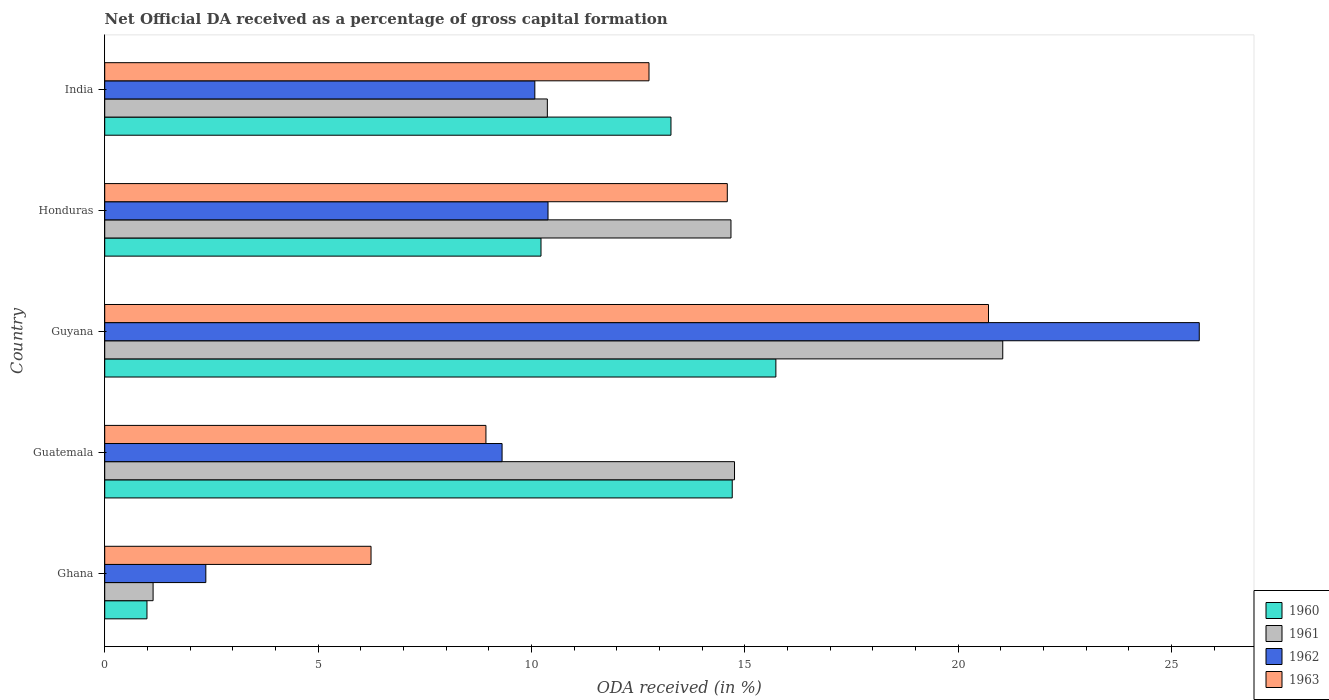Are the number of bars on each tick of the Y-axis equal?
Offer a terse response. Yes. How many bars are there on the 3rd tick from the bottom?
Offer a very short reply. 4. What is the label of the 5th group of bars from the top?
Offer a very short reply. Ghana. In how many cases, is the number of bars for a given country not equal to the number of legend labels?
Provide a succinct answer. 0. What is the net ODA received in 1960 in Honduras?
Offer a terse response. 10.23. Across all countries, what is the maximum net ODA received in 1963?
Make the answer very short. 20.71. Across all countries, what is the minimum net ODA received in 1962?
Make the answer very short. 2.37. In which country was the net ODA received in 1961 maximum?
Your answer should be compact. Guyana. In which country was the net ODA received in 1963 minimum?
Your answer should be compact. Ghana. What is the total net ODA received in 1961 in the graph?
Offer a terse response. 61.99. What is the difference between the net ODA received in 1961 in Guatemala and that in Honduras?
Your answer should be compact. 0.08. What is the difference between the net ODA received in 1962 in Guyana and the net ODA received in 1960 in Guatemala?
Give a very brief answer. 10.95. What is the average net ODA received in 1962 per country?
Give a very brief answer. 11.56. What is the difference between the net ODA received in 1963 and net ODA received in 1961 in Honduras?
Give a very brief answer. -0.09. In how many countries, is the net ODA received in 1962 greater than 24 %?
Give a very brief answer. 1. What is the ratio of the net ODA received in 1961 in Ghana to that in Honduras?
Provide a short and direct response. 0.08. What is the difference between the highest and the second highest net ODA received in 1960?
Your answer should be very brief. 1.02. What is the difference between the highest and the lowest net ODA received in 1960?
Give a very brief answer. 14.74. Is the sum of the net ODA received in 1961 in Ghana and Guyana greater than the maximum net ODA received in 1962 across all countries?
Your answer should be very brief. No. What does the 4th bar from the top in Guatemala represents?
Keep it short and to the point. 1960. What does the 2nd bar from the bottom in Guatemala represents?
Ensure brevity in your answer.  1961. Is it the case that in every country, the sum of the net ODA received in 1960 and net ODA received in 1963 is greater than the net ODA received in 1962?
Your answer should be compact. Yes. Where does the legend appear in the graph?
Provide a succinct answer. Bottom right. How are the legend labels stacked?
Your answer should be very brief. Vertical. What is the title of the graph?
Ensure brevity in your answer.  Net Official DA received as a percentage of gross capital formation. What is the label or title of the X-axis?
Offer a very short reply. ODA received (in %). What is the label or title of the Y-axis?
Your answer should be very brief. Country. What is the ODA received (in %) in 1960 in Ghana?
Offer a terse response. 0.99. What is the ODA received (in %) in 1961 in Ghana?
Keep it short and to the point. 1.13. What is the ODA received (in %) in 1962 in Ghana?
Make the answer very short. 2.37. What is the ODA received (in %) of 1963 in Ghana?
Offer a terse response. 6.24. What is the ODA received (in %) in 1960 in Guatemala?
Provide a short and direct response. 14.71. What is the ODA received (in %) of 1961 in Guatemala?
Your answer should be very brief. 14.76. What is the ODA received (in %) in 1962 in Guatemala?
Ensure brevity in your answer.  9.31. What is the ODA received (in %) in 1963 in Guatemala?
Give a very brief answer. 8.93. What is the ODA received (in %) in 1960 in Guyana?
Offer a very short reply. 15.73. What is the ODA received (in %) of 1961 in Guyana?
Provide a short and direct response. 21.05. What is the ODA received (in %) in 1962 in Guyana?
Keep it short and to the point. 25.65. What is the ODA received (in %) of 1963 in Guyana?
Ensure brevity in your answer.  20.71. What is the ODA received (in %) of 1960 in Honduras?
Your answer should be very brief. 10.23. What is the ODA received (in %) in 1961 in Honduras?
Provide a succinct answer. 14.68. What is the ODA received (in %) of 1962 in Honduras?
Ensure brevity in your answer.  10.39. What is the ODA received (in %) of 1963 in Honduras?
Give a very brief answer. 14.59. What is the ODA received (in %) in 1960 in India?
Offer a terse response. 13.27. What is the ODA received (in %) in 1961 in India?
Your response must be concise. 10.37. What is the ODA received (in %) of 1962 in India?
Offer a terse response. 10.08. What is the ODA received (in %) of 1963 in India?
Offer a terse response. 12.76. Across all countries, what is the maximum ODA received (in %) of 1960?
Provide a succinct answer. 15.73. Across all countries, what is the maximum ODA received (in %) in 1961?
Offer a very short reply. 21.05. Across all countries, what is the maximum ODA received (in %) in 1962?
Make the answer very short. 25.65. Across all countries, what is the maximum ODA received (in %) of 1963?
Your answer should be compact. 20.71. Across all countries, what is the minimum ODA received (in %) in 1960?
Ensure brevity in your answer.  0.99. Across all countries, what is the minimum ODA received (in %) in 1961?
Ensure brevity in your answer.  1.13. Across all countries, what is the minimum ODA received (in %) in 1962?
Your answer should be compact. 2.37. Across all countries, what is the minimum ODA received (in %) in 1963?
Your answer should be very brief. 6.24. What is the total ODA received (in %) in 1960 in the graph?
Provide a short and direct response. 54.92. What is the total ODA received (in %) of 1961 in the graph?
Make the answer very short. 61.99. What is the total ODA received (in %) in 1962 in the graph?
Provide a succinct answer. 57.81. What is the total ODA received (in %) of 1963 in the graph?
Give a very brief answer. 63.24. What is the difference between the ODA received (in %) in 1960 in Ghana and that in Guatemala?
Make the answer very short. -13.72. What is the difference between the ODA received (in %) in 1961 in Ghana and that in Guatemala?
Ensure brevity in your answer.  -13.63. What is the difference between the ODA received (in %) in 1962 in Ghana and that in Guatemala?
Offer a very short reply. -6.94. What is the difference between the ODA received (in %) of 1963 in Ghana and that in Guatemala?
Provide a short and direct response. -2.69. What is the difference between the ODA received (in %) in 1960 in Ghana and that in Guyana?
Keep it short and to the point. -14.74. What is the difference between the ODA received (in %) of 1961 in Ghana and that in Guyana?
Ensure brevity in your answer.  -19.91. What is the difference between the ODA received (in %) in 1962 in Ghana and that in Guyana?
Ensure brevity in your answer.  -23.28. What is the difference between the ODA received (in %) in 1963 in Ghana and that in Guyana?
Your answer should be very brief. -14.47. What is the difference between the ODA received (in %) of 1960 in Ghana and that in Honduras?
Your response must be concise. -9.23. What is the difference between the ODA received (in %) in 1961 in Ghana and that in Honduras?
Your answer should be very brief. -13.54. What is the difference between the ODA received (in %) of 1962 in Ghana and that in Honduras?
Give a very brief answer. -8.02. What is the difference between the ODA received (in %) of 1963 in Ghana and that in Honduras?
Provide a short and direct response. -8.35. What is the difference between the ODA received (in %) in 1960 in Ghana and that in India?
Ensure brevity in your answer.  -12.28. What is the difference between the ODA received (in %) of 1961 in Ghana and that in India?
Keep it short and to the point. -9.24. What is the difference between the ODA received (in %) of 1962 in Ghana and that in India?
Your answer should be compact. -7.71. What is the difference between the ODA received (in %) of 1963 in Ghana and that in India?
Offer a very short reply. -6.51. What is the difference between the ODA received (in %) of 1960 in Guatemala and that in Guyana?
Your answer should be very brief. -1.02. What is the difference between the ODA received (in %) of 1961 in Guatemala and that in Guyana?
Offer a very short reply. -6.29. What is the difference between the ODA received (in %) in 1962 in Guatemala and that in Guyana?
Keep it short and to the point. -16.34. What is the difference between the ODA received (in %) of 1963 in Guatemala and that in Guyana?
Provide a short and direct response. -11.78. What is the difference between the ODA received (in %) of 1960 in Guatemala and that in Honduras?
Give a very brief answer. 4.48. What is the difference between the ODA received (in %) in 1961 in Guatemala and that in Honduras?
Your response must be concise. 0.08. What is the difference between the ODA received (in %) of 1962 in Guatemala and that in Honduras?
Provide a short and direct response. -1.08. What is the difference between the ODA received (in %) in 1963 in Guatemala and that in Honduras?
Provide a short and direct response. -5.66. What is the difference between the ODA received (in %) of 1960 in Guatemala and that in India?
Ensure brevity in your answer.  1.44. What is the difference between the ODA received (in %) in 1961 in Guatemala and that in India?
Keep it short and to the point. 4.39. What is the difference between the ODA received (in %) in 1962 in Guatemala and that in India?
Keep it short and to the point. -0.77. What is the difference between the ODA received (in %) of 1963 in Guatemala and that in India?
Your answer should be very brief. -3.82. What is the difference between the ODA received (in %) of 1960 in Guyana and that in Honduras?
Your response must be concise. 5.5. What is the difference between the ODA received (in %) in 1961 in Guyana and that in Honduras?
Your answer should be compact. 6.37. What is the difference between the ODA received (in %) of 1962 in Guyana and that in Honduras?
Your response must be concise. 15.26. What is the difference between the ODA received (in %) of 1963 in Guyana and that in Honduras?
Your response must be concise. 6.12. What is the difference between the ODA received (in %) of 1960 in Guyana and that in India?
Ensure brevity in your answer.  2.46. What is the difference between the ODA received (in %) in 1961 in Guyana and that in India?
Offer a terse response. 10.67. What is the difference between the ODA received (in %) in 1962 in Guyana and that in India?
Give a very brief answer. 15.57. What is the difference between the ODA received (in %) of 1963 in Guyana and that in India?
Offer a very short reply. 7.96. What is the difference between the ODA received (in %) in 1960 in Honduras and that in India?
Give a very brief answer. -3.05. What is the difference between the ODA received (in %) in 1961 in Honduras and that in India?
Your response must be concise. 4.3. What is the difference between the ODA received (in %) in 1962 in Honduras and that in India?
Give a very brief answer. 0.31. What is the difference between the ODA received (in %) of 1963 in Honduras and that in India?
Give a very brief answer. 1.84. What is the difference between the ODA received (in %) of 1960 in Ghana and the ODA received (in %) of 1961 in Guatemala?
Offer a very short reply. -13.77. What is the difference between the ODA received (in %) of 1960 in Ghana and the ODA received (in %) of 1962 in Guatemala?
Give a very brief answer. -8.32. What is the difference between the ODA received (in %) of 1960 in Ghana and the ODA received (in %) of 1963 in Guatemala?
Offer a very short reply. -7.94. What is the difference between the ODA received (in %) in 1961 in Ghana and the ODA received (in %) in 1962 in Guatemala?
Give a very brief answer. -8.18. What is the difference between the ODA received (in %) of 1961 in Ghana and the ODA received (in %) of 1963 in Guatemala?
Offer a terse response. -7.8. What is the difference between the ODA received (in %) of 1962 in Ghana and the ODA received (in %) of 1963 in Guatemala?
Keep it short and to the point. -6.56. What is the difference between the ODA received (in %) of 1960 in Ghana and the ODA received (in %) of 1961 in Guyana?
Provide a succinct answer. -20.06. What is the difference between the ODA received (in %) in 1960 in Ghana and the ODA received (in %) in 1962 in Guyana?
Provide a short and direct response. -24.66. What is the difference between the ODA received (in %) in 1960 in Ghana and the ODA received (in %) in 1963 in Guyana?
Make the answer very short. -19.72. What is the difference between the ODA received (in %) of 1961 in Ghana and the ODA received (in %) of 1962 in Guyana?
Give a very brief answer. -24.52. What is the difference between the ODA received (in %) in 1961 in Ghana and the ODA received (in %) in 1963 in Guyana?
Provide a short and direct response. -19.58. What is the difference between the ODA received (in %) of 1962 in Ghana and the ODA received (in %) of 1963 in Guyana?
Ensure brevity in your answer.  -18.34. What is the difference between the ODA received (in %) of 1960 in Ghana and the ODA received (in %) of 1961 in Honduras?
Offer a terse response. -13.69. What is the difference between the ODA received (in %) in 1960 in Ghana and the ODA received (in %) in 1962 in Honduras?
Ensure brevity in your answer.  -9.4. What is the difference between the ODA received (in %) in 1960 in Ghana and the ODA received (in %) in 1963 in Honduras?
Provide a succinct answer. -13.6. What is the difference between the ODA received (in %) in 1961 in Ghana and the ODA received (in %) in 1962 in Honduras?
Give a very brief answer. -9.26. What is the difference between the ODA received (in %) of 1961 in Ghana and the ODA received (in %) of 1963 in Honduras?
Provide a succinct answer. -13.46. What is the difference between the ODA received (in %) in 1962 in Ghana and the ODA received (in %) in 1963 in Honduras?
Your answer should be compact. -12.22. What is the difference between the ODA received (in %) in 1960 in Ghana and the ODA received (in %) in 1961 in India?
Provide a short and direct response. -9.38. What is the difference between the ODA received (in %) in 1960 in Ghana and the ODA received (in %) in 1962 in India?
Ensure brevity in your answer.  -9.09. What is the difference between the ODA received (in %) of 1960 in Ghana and the ODA received (in %) of 1963 in India?
Provide a succinct answer. -11.77. What is the difference between the ODA received (in %) in 1961 in Ghana and the ODA received (in %) in 1962 in India?
Provide a short and direct response. -8.95. What is the difference between the ODA received (in %) in 1961 in Ghana and the ODA received (in %) in 1963 in India?
Your answer should be very brief. -11.62. What is the difference between the ODA received (in %) of 1962 in Ghana and the ODA received (in %) of 1963 in India?
Make the answer very short. -10.39. What is the difference between the ODA received (in %) in 1960 in Guatemala and the ODA received (in %) in 1961 in Guyana?
Provide a short and direct response. -6.34. What is the difference between the ODA received (in %) of 1960 in Guatemala and the ODA received (in %) of 1962 in Guyana?
Make the answer very short. -10.95. What is the difference between the ODA received (in %) in 1960 in Guatemala and the ODA received (in %) in 1963 in Guyana?
Your answer should be very brief. -6.01. What is the difference between the ODA received (in %) in 1961 in Guatemala and the ODA received (in %) in 1962 in Guyana?
Ensure brevity in your answer.  -10.89. What is the difference between the ODA received (in %) in 1961 in Guatemala and the ODA received (in %) in 1963 in Guyana?
Make the answer very short. -5.95. What is the difference between the ODA received (in %) in 1962 in Guatemala and the ODA received (in %) in 1963 in Guyana?
Offer a terse response. -11.4. What is the difference between the ODA received (in %) of 1960 in Guatemala and the ODA received (in %) of 1961 in Honduras?
Offer a terse response. 0.03. What is the difference between the ODA received (in %) in 1960 in Guatemala and the ODA received (in %) in 1962 in Honduras?
Give a very brief answer. 4.32. What is the difference between the ODA received (in %) in 1960 in Guatemala and the ODA received (in %) in 1963 in Honduras?
Provide a short and direct response. 0.12. What is the difference between the ODA received (in %) in 1961 in Guatemala and the ODA received (in %) in 1962 in Honduras?
Make the answer very short. 4.37. What is the difference between the ODA received (in %) of 1961 in Guatemala and the ODA received (in %) of 1963 in Honduras?
Your response must be concise. 0.17. What is the difference between the ODA received (in %) in 1962 in Guatemala and the ODA received (in %) in 1963 in Honduras?
Give a very brief answer. -5.28. What is the difference between the ODA received (in %) of 1960 in Guatemala and the ODA received (in %) of 1961 in India?
Give a very brief answer. 4.33. What is the difference between the ODA received (in %) of 1960 in Guatemala and the ODA received (in %) of 1962 in India?
Your response must be concise. 4.63. What is the difference between the ODA received (in %) of 1960 in Guatemala and the ODA received (in %) of 1963 in India?
Offer a terse response. 1.95. What is the difference between the ODA received (in %) in 1961 in Guatemala and the ODA received (in %) in 1962 in India?
Provide a succinct answer. 4.68. What is the difference between the ODA received (in %) of 1961 in Guatemala and the ODA received (in %) of 1963 in India?
Ensure brevity in your answer.  2. What is the difference between the ODA received (in %) in 1962 in Guatemala and the ODA received (in %) in 1963 in India?
Offer a terse response. -3.44. What is the difference between the ODA received (in %) in 1960 in Guyana and the ODA received (in %) in 1961 in Honduras?
Offer a terse response. 1.05. What is the difference between the ODA received (in %) of 1960 in Guyana and the ODA received (in %) of 1962 in Honduras?
Keep it short and to the point. 5.34. What is the difference between the ODA received (in %) of 1960 in Guyana and the ODA received (in %) of 1963 in Honduras?
Your answer should be very brief. 1.14. What is the difference between the ODA received (in %) of 1961 in Guyana and the ODA received (in %) of 1962 in Honduras?
Give a very brief answer. 10.66. What is the difference between the ODA received (in %) of 1961 in Guyana and the ODA received (in %) of 1963 in Honduras?
Your response must be concise. 6.46. What is the difference between the ODA received (in %) in 1962 in Guyana and the ODA received (in %) in 1963 in Honduras?
Your answer should be very brief. 11.06. What is the difference between the ODA received (in %) of 1960 in Guyana and the ODA received (in %) of 1961 in India?
Provide a succinct answer. 5.36. What is the difference between the ODA received (in %) in 1960 in Guyana and the ODA received (in %) in 1962 in India?
Give a very brief answer. 5.65. What is the difference between the ODA received (in %) of 1960 in Guyana and the ODA received (in %) of 1963 in India?
Your answer should be very brief. 2.97. What is the difference between the ODA received (in %) in 1961 in Guyana and the ODA received (in %) in 1962 in India?
Give a very brief answer. 10.97. What is the difference between the ODA received (in %) of 1961 in Guyana and the ODA received (in %) of 1963 in India?
Make the answer very short. 8.29. What is the difference between the ODA received (in %) in 1962 in Guyana and the ODA received (in %) in 1963 in India?
Provide a short and direct response. 12.9. What is the difference between the ODA received (in %) in 1960 in Honduras and the ODA received (in %) in 1961 in India?
Provide a short and direct response. -0.15. What is the difference between the ODA received (in %) of 1960 in Honduras and the ODA received (in %) of 1962 in India?
Give a very brief answer. 0.14. What is the difference between the ODA received (in %) in 1960 in Honduras and the ODA received (in %) in 1963 in India?
Your answer should be compact. -2.53. What is the difference between the ODA received (in %) of 1961 in Honduras and the ODA received (in %) of 1962 in India?
Give a very brief answer. 4.6. What is the difference between the ODA received (in %) in 1961 in Honduras and the ODA received (in %) in 1963 in India?
Offer a very short reply. 1.92. What is the difference between the ODA received (in %) in 1962 in Honduras and the ODA received (in %) in 1963 in India?
Make the answer very short. -2.37. What is the average ODA received (in %) of 1960 per country?
Your answer should be very brief. 10.98. What is the average ODA received (in %) of 1961 per country?
Make the answer very short. 12.4. What is the average ODA received (in %) of 1962 per country?
Keep it short and to the point. 11.56. What is the average ODA received (in %) in 1963 per country?
Make the answer very short. 12.65. What is the difference between the ODA received (in %) of 1960 and ODA received (in %) of 1961 in Ghana?
Your answer should be compact. -0.14. What is the difference between the ODA received (in %) in 1960 and ODA received (in %) in 1962 in Ghana?
Make the answer very short. -1.38. What is the difference between the ODA received (in %) of 1960 and ODA received (in %) of 1963 in Ghana?
Provide a succinct answer. -5.25. What is the difference between the ODA received (in %) in 1961 and ODA received (in %) in 1962 in Ghana?
Provide a succinct answer. -1.24. What is the difference between the ODA received (in %) of 1961 and ODA received (in %) of 1963 in Ghana?
Keep it short and to the point. -5.11. What is the difference between the ODA received (in %) in 1962 and ODA received (in %) in 1963 in Ghana?
Offer a very short reply. -3.87. What is the difference between the ODA received (in %) in 1960 and ODA received (in %) in 1961 in Guatemala?
Provide a succinct answer. -0.05. What is the difference between the ODA received (in %) of 1960 and ODA received (in %) of 1962 in Guatemala?
Make the answer very short. 5.39. What is the difference between the ODA received (in %) in 1960 and ODA received (in %) in 1963 in Guatemala?
Offer a terse response. 5.77. What is the difference between the ODA received (in %) in 1961 and ODA received (in %) in 1962 in Guatemala?
Provide a succinct answer. 5.45. What is the difference between the ODA received (in %) of 1961 and ODA received (in %) of 1963 in Guatemala?
Ensure brevity in your answer.  5.83. What is the difference between the ODA received (in %) in 1962 and ODA received (in %) in 1963 in Guatemala?
Keep it short and to the point. 0.38. What is the difference between the ODA received (in %) in 1960 and ODA received (in %) in 1961 in Guyana?
Keep it short and to the point. -5.32. What is the difference between the ODA received (in %) of 1960 and ODA received (in %) of 1962 in Guyana?
Provide a short and direct response. -9.92. What is the difference between the ODA received (in %) in 1960 and ODA received (in %) in 1963 in Guyana?
Give a very brief answer. -4.98. What is the difference between the ODA received (in %) in 1961 and ODA received (in %) in 1962 in Guyana?
Ensure brevity in your answer.  -4.61. What is the difference between the ODA received (in %) of 1961 and ODA received (in %) of 1963 in Guyana?
Provide a succinct answer. 0.33. What is the difference between the ODA received (in %) in 1962 and ODA received (in %) in 1963 in Guyana?
Your response must be concise. 4.94. What is the difference between the ODA received (in %) in 1960 and ODA received (in %) in 1961 in Honduras?
Provide a short and direct response. -4.45. What is the difference between the ODA received (in %) in 1960 and ODA received (in %) in 1962 in Honduras?
Offer a very short reply. -0.16. What is the difference between the ODA received (in %) in 1960 and ODA received (in %) in 1963 in Honduras?
Give a very brief answer. -4.37. What is the difference between the ODA received (in %) in 1961 and ODA received (in %) in 1962 in Honduras?
Offer a very short reply. 4.29. What is the difference between the ODA received (in %) of 1961 and ODA received (in %) of 1963 in Honduras?
Give a very brief answer. 0.09. What is the difference between the ODA received (in %) in 1962 and ODA received (in %) in 1963 in Honduras?
Keep it short and to the point. -4.2. What is the difference between the ODA received (in %) in 1960 and ODA received (in %) in 1961 in India?
Provide a short and direct response. 2.9. What is the difference between the ODA received (in %) in 1960 and ODA received (in %) in 1962 in India?
Keep it short and to the point. 3.19. What is the difference between the ODA received (in %) in 1960 and ODA received (in %) in 1963 in India?
Your answer should be very brief. 0.52. What is the difference between the ODA received (in %) of 1961 and ODA received (in %) of 1962 in India?
Your answer should be very brief. 0.29. What is the difference between the ODA received (in %) of 1961 and ODA received (in %) of 1963 in India?
Provide a short and direct response. -2.38. What is the difference between the ODA received (in %) in 1962 and ODA received (in %) in 1963 in India?
Offer a very short reply. -2.68. What is the ratio of the ODA received (in %) in 1960 in Ghana to that in Guatemala?
Provide a succinct answer. 0.07. What is the ratio of the ODA received (in %) in 1961 in Ghana to that in Guatemala?
Offer a very short reply. 0.08. What is the ratio of the ODA received (in %) in 1962 in Ghana to that in Guatemala?
Provide a short and direct response. 0.25. What is the ratio of the ODA received (in %) of 1963 in Ghana to that in Guatemala?
Your answer should be compact. 0.7. What is the ratio of the ODA received (in %) of 1960 in Ghana to that in Guyana?
Your answer should be very brief. 0.06. What is the ratio of the ODA received (in %) in 1961 in Ghana to that in Guyana?
Ensure brevity in your answer.  0.05. What is the ratio of the ODA received (in %) in 1962 in Ghana to that in Guyana?
Ensure brevity in your answer.  0.09. What is the ratio of the ODA received (in %) of 1963 in Ghana to that in Guyana?
Offer a terse response. 0.3. What is the ratio of the ODA received (in %) of 1960 in Ghana to that in Honduras?
Provide a succinct answer. 0.1. What is the ratio of the ODA received (in %) in 1961 in Ghana to that in Honduras?
Your answer should be compact. 0.08. What is the ratio of the ODA received (in %) of 1962 in Ghana to that in Honduras?
Your response must be concise. 0.23. What is the ratio of the ODA received (in %) in 1963 in Ghana to that in Honduras?
Provide a succinct answer. 0.43. What is the ratio of the ODA received (in %) of 1960 in Ghana to that in India?
Ensure brevity in your answer.  0.07. What is the ratio of the ODA received (in %) of 1961 in Ghana to that in India?
Make the answer very short. 0.11. What is the ratio of the ODA received (in %) in 1962 in Ghana to that in India?
Keep it short and to the point. 0.24. What is the ratio of the ODA received (in %) of 1963 in Ghana to that in India?
Your answer should be very brief. 0.49. What is the ratio of the ODA received (in %) of 1960 in Guatemala to that in Guyana?
Provide a succinct answer. 0.94. What is the ratio of the ODA received (in %) of 1961 in Guatemala to that in Guyana?
Provide a succinct answer. 0.7. What is the ratio of the ODA received (in %) of 1962 in Guatemala to that in Guyana?
Your response must be concise. 0.36. What is the ratio of the ODA received (in %) of 1963 in Guatemala to that in Guyana?
Make the answer very short. 0.43. What is the ratio of the ODA received (in %) in 1960 in Guatemala to that in Honduras?
Make the answer very short. 1.44. What is the ratio of the ODA received (in %) of 1962 in Guatemala to that in Honduras?
Offer a terse response. 0.9. What is the ratio of the ODA received (in %) in 1963 in Guatemala to that in Honduras?
Offer a terse response. 0.61. What is the ratio of the ODA received (in %) of 1960 in Guatemala to that in India?
Provide a short and direct response. 1.11. What is the ratio of the ODA received (in %) in 1961 in Guatemala to that in India?
Give a very brief answer. 1.42. What is the ratio of the ODA received (in %) of 1962 in Guatemala to that in India?
Give a very brief answer. 0.92. What is the ratio of the ODA received (in %) of 1963 in Guatemala to that in India?
Keep it short and to the point. 0.7. What is the ratio of the ODA received (in %) of 1960 in Guyana to that in Honduras?
Keep it short and to the point. 1.54. What is the ratio of the ODA received (in %) in 1961 in Guyana to that in Honduras?
Your answer should be very brief. 1.43. What is the ratio of the ODA received (in %) in 1962 in Guyana to that in Honduras?
Offer a terse response. 2.47. What is the ratio of the ODA received (in %) in 1963 in Guyana to that in Honduras?
Your answer should be very brief. 1.42. What is the ratio of the ODA received (in %) of 1960 in Guyana to that in India?
Provide a short and direct response. 1.19. What is the ratio of the ODA received (in %) of 1961 in Guyana to that in India?
Offer a very short reply. 2.03. What is the ratio of the ODA received (in %) of 1962 in Guyana to that in India?
Give a very brief answer. 2.54. What is the ratio of the ODA received (in %) in 1963 in Guyana to that in India?
Offer a very short reply. 1.62. What is the ratio of the ODA received (in %) of 1960 in Honduras to that in India?
Provide a succinct answer. 0.77. What is the ratio of the ODA received (in %) of 1961 in Honduras to that in India?
Make the answer very short. 1.41. What is the ratio of the ODA received (in %) of 1962 in Honduras to that in India?
Offer a terse response. 1.03. What is the ratio of the ODA received (in %) of 1963 in Honduras to that in India?
Provide a short and direct response. 1.14. What is the difference between the highest and the second highest ODA received (in %) of 1960?
Make the answer very short. 1.02. What is the difference between the highest and the second highest ODA received (in %) in 1961?
Your response must be concise. 6.29. What is the difference between the highest and the second highest ODA received (in %) in 1962?
Offer a very short reply. 15.26. What is the difference between the highest and the second highest ODA received (in %) of 1963?
Ensure brevity in your answer.  6.12. What is the difference between the highest and the lowest ODA received (in %) of 1960?
Provide a succinct answer. 14.74. What is the difference between the highest and the lowest ODA received (in %) of 1961?
Your answer should be compact. 19.91. What is the difference between the highest and the lowest ODA received (in %) in 1962?
Offer a very short reply. 23.28. What is the difference between the highest and the lowest ODA received (in %) in 1963?
Keep it short and to the point. 14.47. 